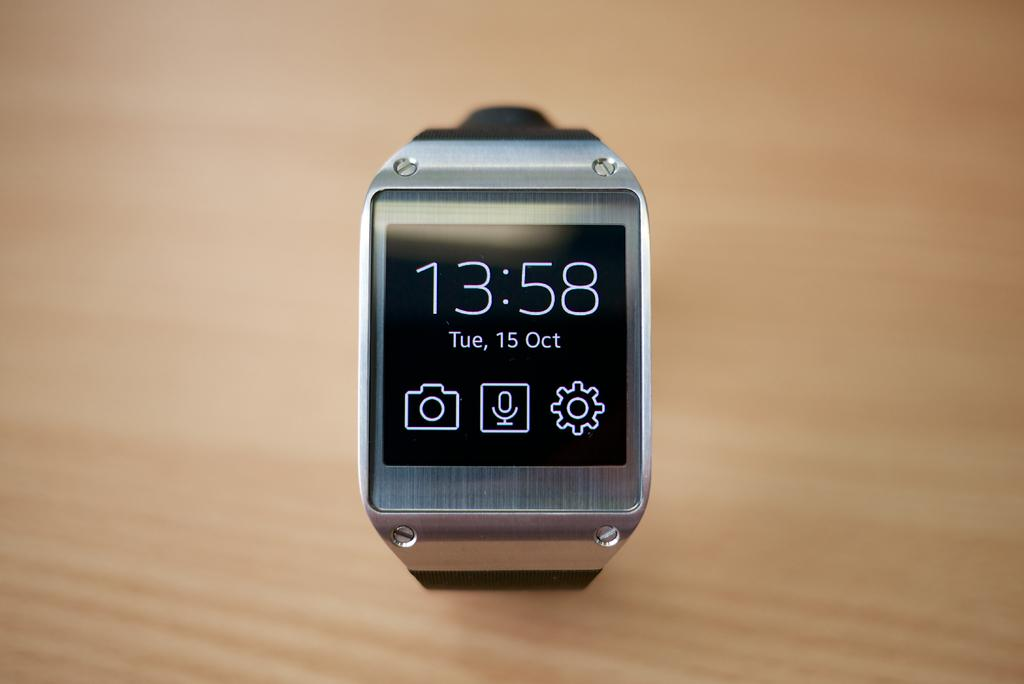Provide a one-sentence caption for the provided image. A digital watch with 13:58 on the face. 